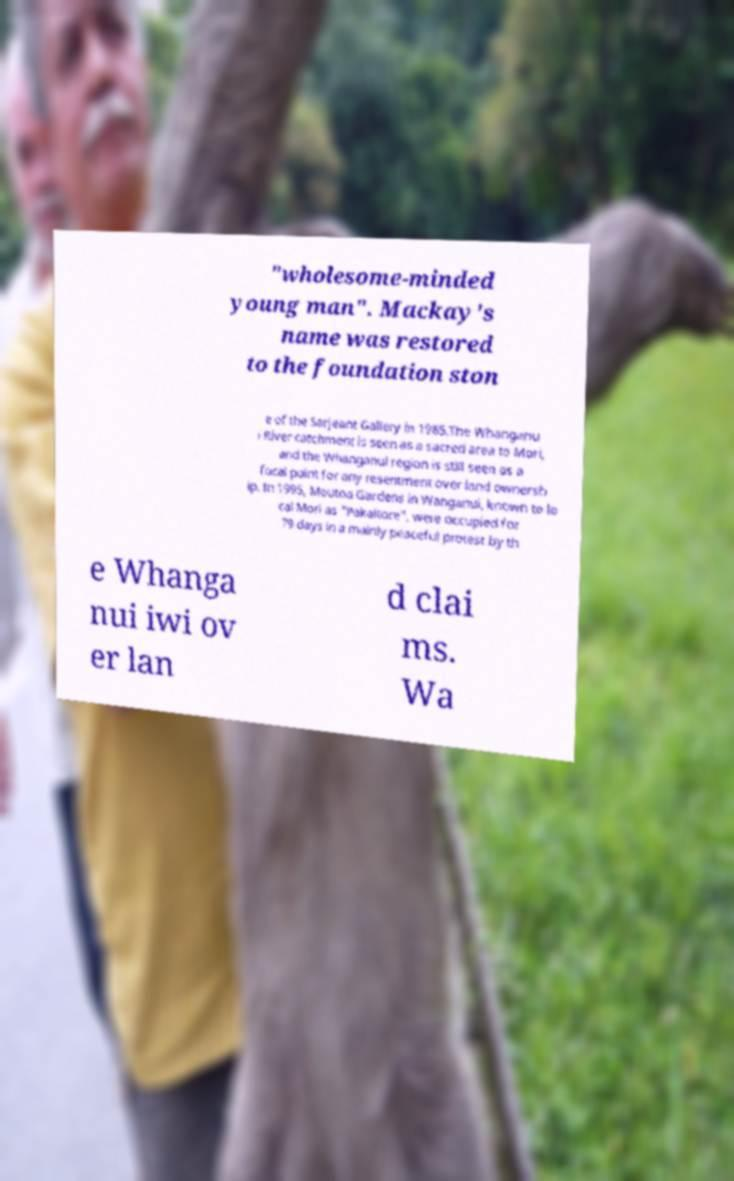There's text embedded in this image that I need extracted. Can you transcribe it verbatim? "wholesome-minded young man". Mackay's name was restored to the foundation ston e of the Sarjeant Gallery in 1985.The Whanganu i River catchment is seen as a sacred area to Mori, and the Whanganui region is still seen as a focal point for any resentment over land ownersh ip. In 1995, Moutoa Gardens in Wanganui, known to lo cal Mori as "Pakaitore", were occupied for 79 days in a mainly peaceful protest by th e Whanga nui iwi ov er lan d clai ms. Wa 